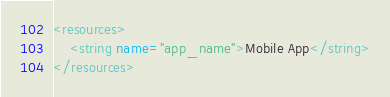<code> <loc_0><loc_0><loc_500><loc_500><_XML_><resources>
    <string name="app_name">Mobile App</string>
</resources></code> 